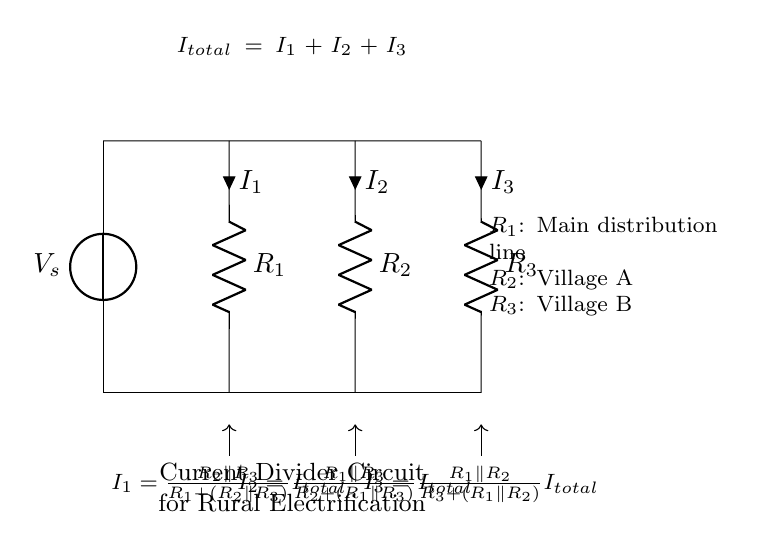What is the total current entering the circuit? The total current entering the circuit is denoted by I total, which is the sum of the individual currents I1, I2, and I3 flowing through the resistors.
Answer: I total What is the resistance of the main distribution line? The resistance of the main distribution line is denoted by R1, which is labeled on the diagram as R equals 1.
Answer: R1 How many branches are in the current divider circuit? The current divider circuit has three branches, represented by the three resistors R1, R2, and R3, each of which allows current to flow through them.
Answer: Three Which resistor corresponds to Village A? The resistor corresponding to Village A is labeled R2 in the circuit diagram.
Answer: R2 What is the direction of the current flow through R3? The direction of current flow through R3 is downward, indicated by the arrow associated with current I3 pointing away from the resistor.
Answer: Downward 